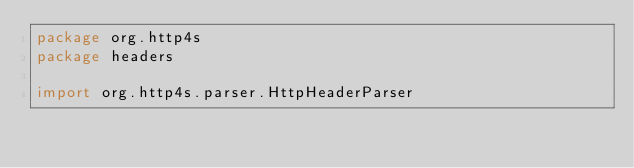<code> <loc_0><loc_0><loc_500><loc_500><_Scala_>package org.http4s
package headers

import org.http4s.parser.HttpHeaderParser</code> 